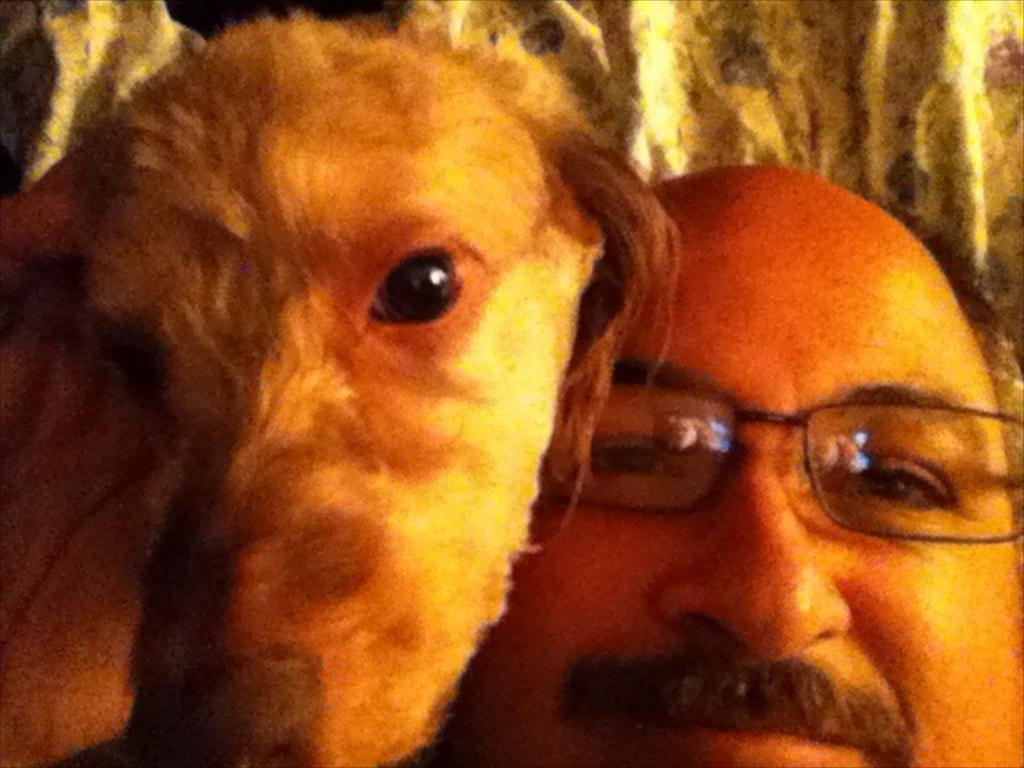Who is present in the image? There is a man in the image. What is the man doing in the image? The man is smiling in the image. What accessory is the man wearing? The man is wearing spectacles in the image. What other living creature is in the image? There is a dog in the image. What object can be seen in the background of the image? There is a pillow in the background of the image. What type of popcorn is the man eating in the image? There is no popcorn present in the image; the man is not eating anything. How does the man interact with his brother in the image? There is no mention of a brother in the image, so it is not possible to answer this question. 